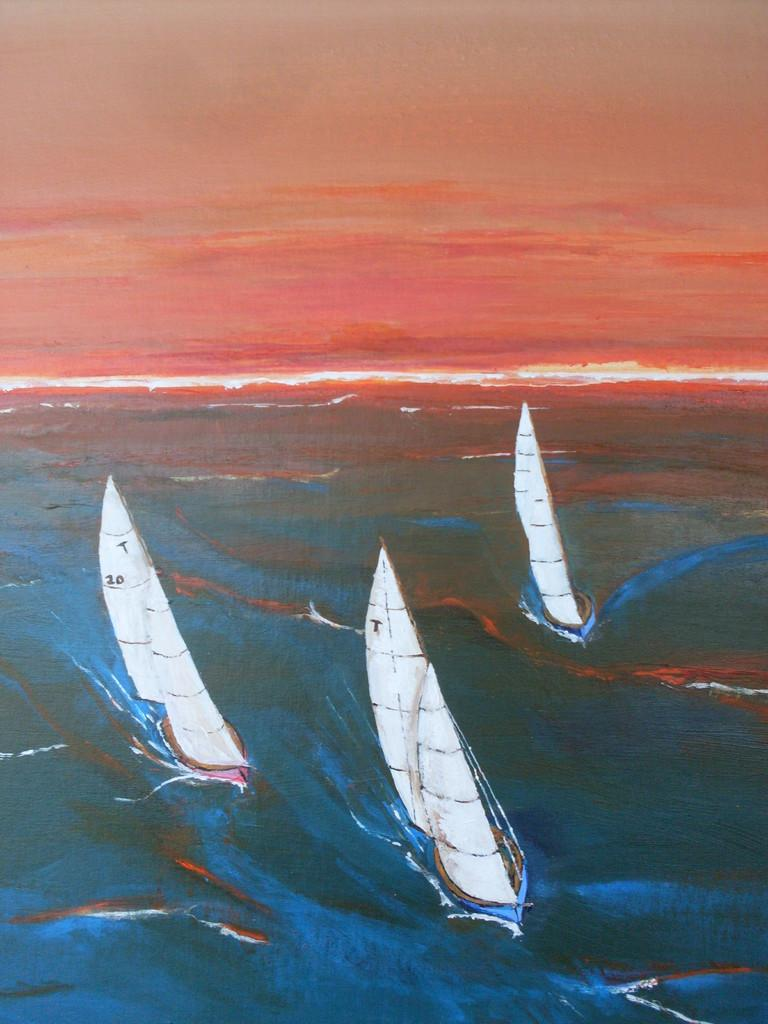Provide a one-sentence caption for the provided image. the sails on the boat are white and going through rough water. 